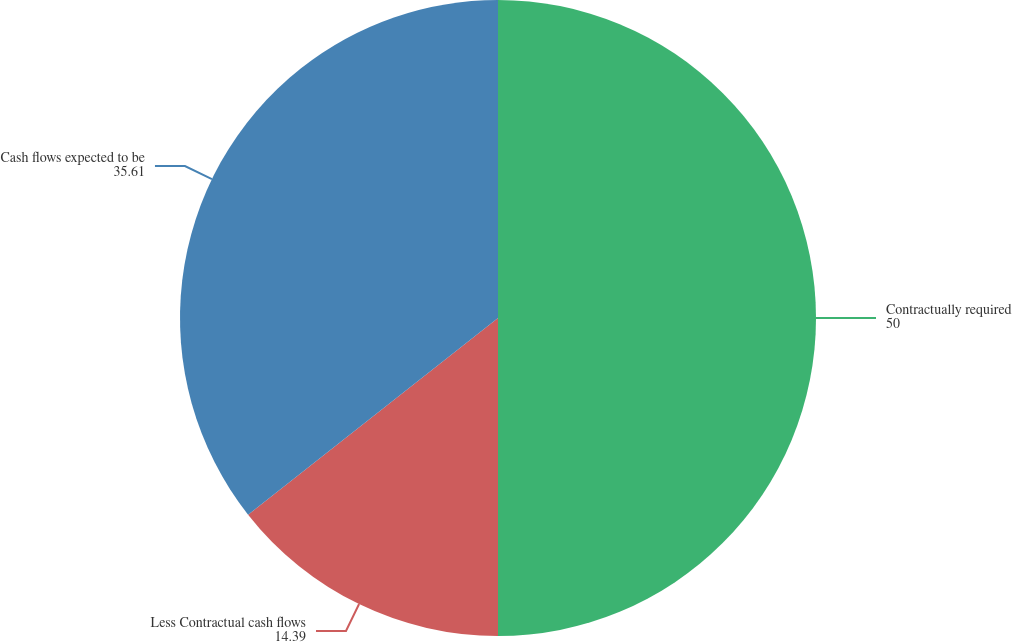Convert chart. <chart><loc_0><loc_0><loc_500><loc_500><pie_chart><fcel>Contractually required<fcel>Less Contractual cash flows<fcel>Cash flows expected to be<nl><fcel>50.0%<fcel>14.39%<fcel>35.61%<nl></chart> 